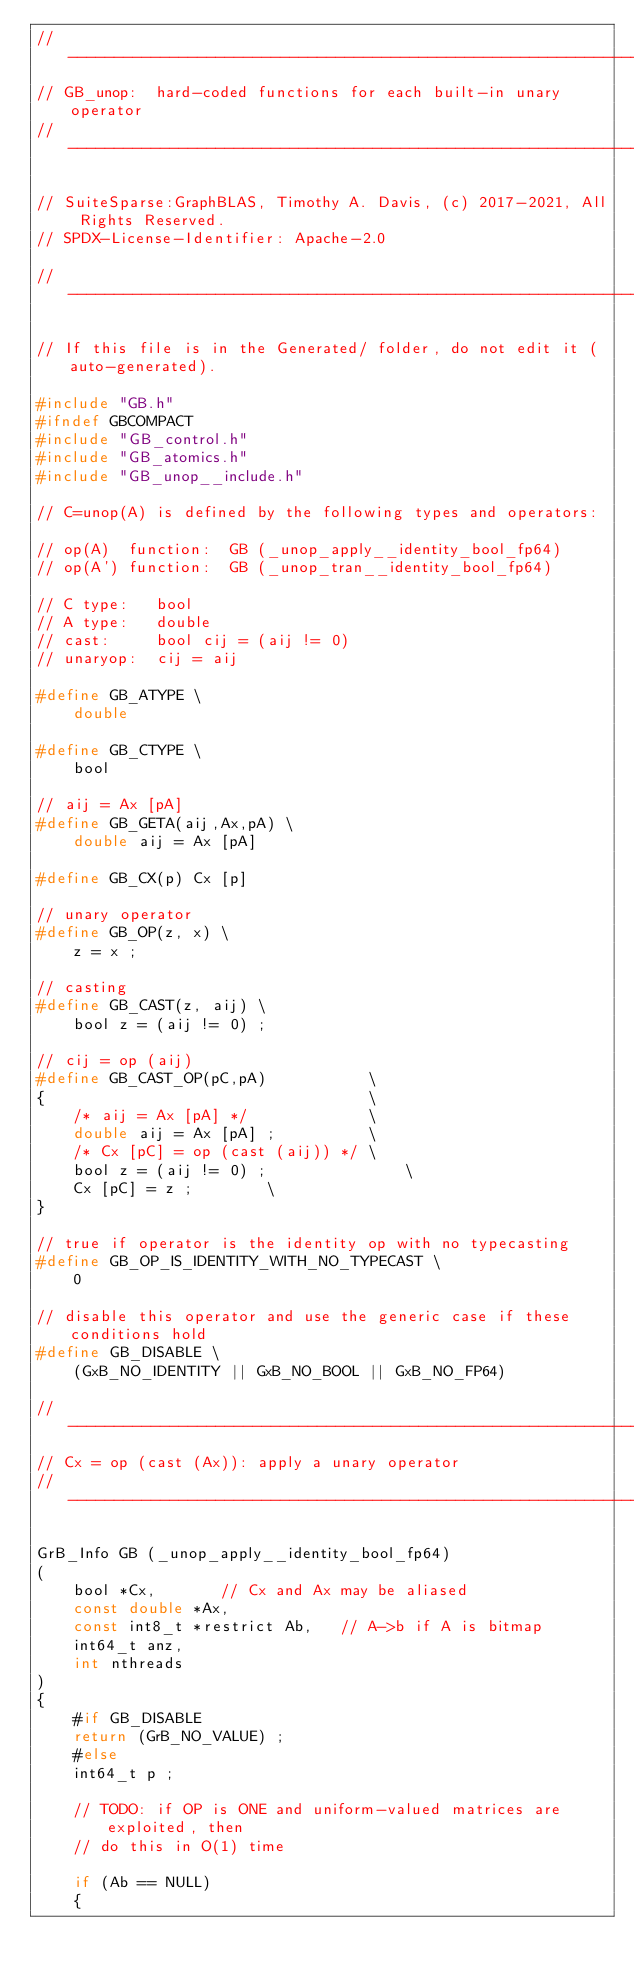<code> <loc_0><loc_0><loc_500><loc_500><_C_>//------------------------------------------------------------------------------
// GB_unop:  hard-coded functions for each built-in unary operator
//------------------------------------------------------------------------------

// SuiteSparse:GraphBLAS, Timothy A. Davis, (c) 2017-2021, All Rights Reserved.
// SPDX-License-Identifier: Apache-2.0

//------------------------------------------------------------------------------

// If this file is in the Generated/ folder, do not edit it (auto-generated).

#include "GB.h"
#ifndef GBCOMPACT
#include "GB_control.h"
#include "GB_atomics.h"
#include "GB_unop__include.h"

// C=unop(A) is defined by the following types and operators:

// op(A)  function:  GB (_unop_apply__identity_bool_fp64)
// op(A') function:  GB (_unop_tran__identity_bool_fp64)

// C type:   bool
// A type:   double
// cast:     bool cij = (aij != 0)
// unaryop:  cij = aij

#define GB_ATYPE \
    double

#define GB_CTYPE \
    bool

// aij = Ax [pA]
#define GB_GETA(aij,Ax,pA) \
    double aij = Ax [pA]

#define GB_CX(p) Cx [p]

// unary operator
#define GB_OP(z, x) \
    z = x ;

// casting
#define GB_CAST(z, aij) \
    bool z = (aij != 0) ;

// cij = op (aij)
#define GB_CAST_OP(pC,pA)           \
{                                   \
    /* aij = Ax [pA] */             \
    double aij = Ax [pA] ;          \
    /* Cx [pC] = op (cast (aij)) */ \
    bool z = (aij != 0) ;               \
    Cx [pC] = z ;        \
}

// true if operator is the identity op with no typecasting
#define GB_OP_IS_IDENTITY_WITH_NO_TYPECAST \
    0

// disable this operator and use the generic case if these conditions hold
#define GB_DISABLE \
    (GxB_NO_IDENTITY || GxB_NO_BOOL || GxB_NO_FP64)

//------------------------------------------------------------------------------
// Cx = op (cast (Ax)): apply a unary operator
//------------------------------------------------------------------------------

GrB_Info GB (_unop_apply__identity_bool_fp64)
(
    bool *Cx,       // Cx and Ax may be aliased
    const double *Ax,
    const int8_t *restrict Ab,   // A->b if A is bitmap
    int64_t anz,
    int nthreads
)
{
    #if GB_DISABLE
    return (GrB_NO_VALUE) ;
    #else
    int64_t p ;

    // TODO: if OP is ONE and uniform-valued matrices are exploited, then
    // do this in O(1) time

    if (Ab == NULL)
    { </code> 